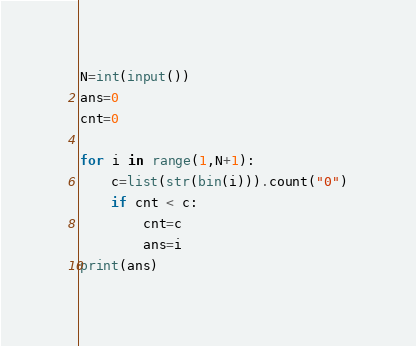Convert code to text. <code><loc_0><loc_0><loc_500><loc_500><_Python_>N=int(input())
ans=0
cnt=0

for i in range(1,N+1):
    c=list(str(bin(i))).count("0")
    if cnt < c:
        cnt=c
        ans=i
print(ans)</code> 